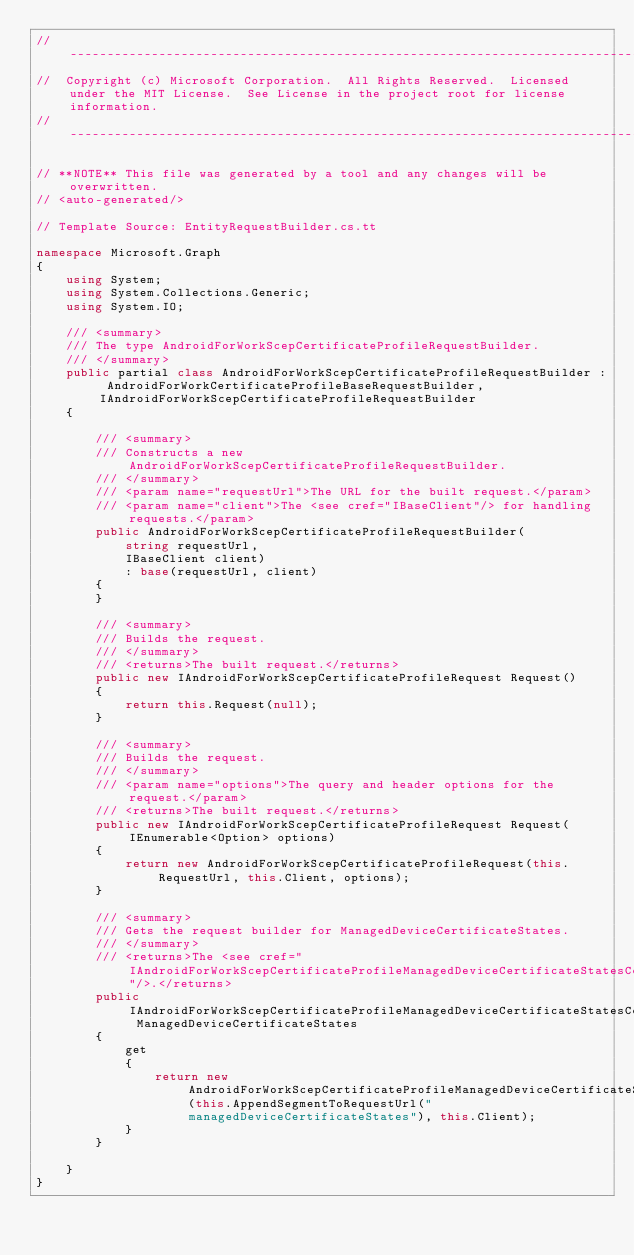<code> <loc_0><loc_0><loc_500><loc_500><_C#_>// ------------------------------------------------------------------------------
//  Copyright (c) Microsoft Corporation.  All Rights Reserved.  Licensed under the MIT License.  See License in the project root for license information.
// ------------------------------------------------------------------------------

// **NOTE** This file was generated by a tool and any changes will be overwritten.
// <auto-generated/>

// Template Source: EntityRequestBuilder.cs.tt

namespace Microsoft.Graph
{
    using System;
    using System.Collections.Generic;
    using System.IO;

    /// <summary>
    /// The type AndroidForWorkScepCertificateProfileRequestBuilder.
    /// </summary>
    public partial class AndroidForWorkScepCertificateProfileRequestBuilder : AndroidForWorkCertificateProfileBaseRequestBuilder, IAndroidForWorkScepCertificateProfileRequestBuilder
    {

        /// <summary>
        /// Constructs a new AndroidForWorkScepCertificateProfileRequestBuilder.
        /// </summary>
        /// <param name="requestUrl">The URL for the built request.</param>
        /// <param name="client">The <see cref="IBaseClient"/> for handling requests.</param>
        public AndroidForWorkScepCertificateProfileRequestBuilder(
            string requestUrl,
            IBaseClient client)
            : base(requestUrl, client)
        {
        }

        /// <summary>
        /// Builds the request.
        /// </summary>
        /// <returns>The built request.</returns>
        public new IAndroidForWorkScepCertificateProfileRequest Request()
        {
            return this.Request(null);
        }

        /// <summary>
        /// Builds the request.
        /// </summary>
        /// <param name="options">The query and header options for the request.</param>
        /// <returns>The built request.</returns>
        public new IAndroidForWorkScepCertificateProfileRequest Request(IEnumerable<Option> options)
        {
            return new AndroidForWorkScepCertificateProfileRequest(this.RequestUrl, this.Client, options);
        }
    
        /// <summary>
        /// Gets the request builder for ManagedDeviceCertificateStates.
        /// </summary>
        /// <returns>The <see cref="IAndroidForWorkScepCertificateProfileManagedDeviceCertificateStatesCollectionRequestBuilder"/>.</returns>
        public IAndroidForWorkScepCertificateProfileManagedDeviceCertificateStatesCollectionRequestBuilder ManagedDeviceCertificateStates
        {
            get
            {
                return new AndroidForWorkScepCertificateProfileManagedDeviceCertificateStatesCollectionRequestBuilder(this.AppendSegmentToRequestUrl("managedDeviceCertificateStates"), this.Client);
            }
        }
    
    }
}
</code> 